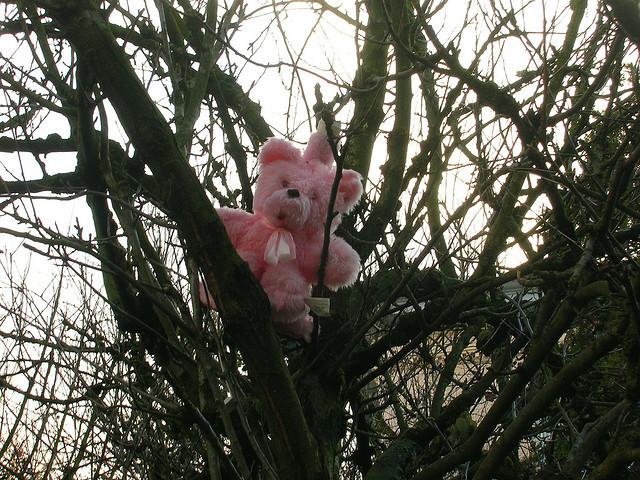What color is the bear?
Be succinct. Pink. Is the plush on a bush?
Give a very brief answer. Yes. Is this in a forest?
Keep it brief. Yes. 